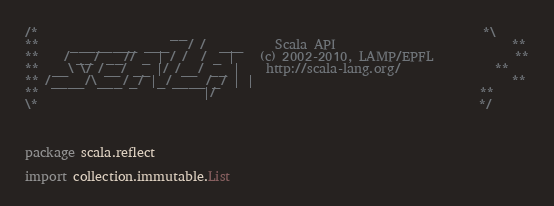<code> <loc_0><loc_0><loc_500><loc_500><_Scala_>/*                     __                                               *\
**     ________ ___   / /  ___     Scala API                            **
**    / __/ __// _ | / /  / _ |    (c) 2002-2010, LAMP/EPFL             **
**  __\ \/ /__/ __ |/ /__/ __ |    http://scala-lang.org/               **
** /____/\___/_/ |_/____/_/ | |                                         **
**                          |/                                          **
\*                                                                      */



package scala.reflect

import collection.immutable.List
</code> 